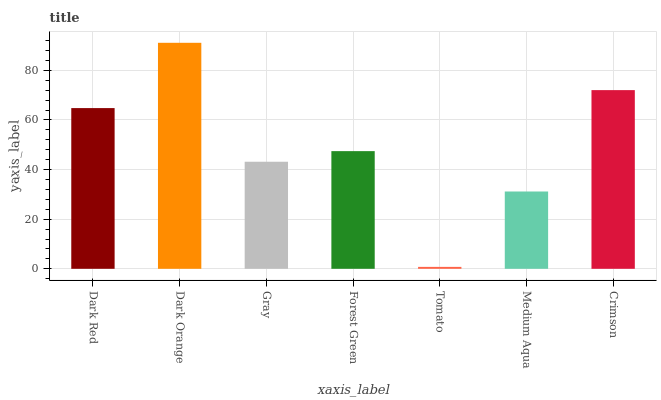Is Tomato the minimum?
Answer yes or no. Yes. Is Dark Orange the maximum?
Answer yes or no. Yes. Is Gray the minimum?
Answer yes or no. No. Is Gray the maximum?
Answer yes or no. No. Is Dark Orange greater than Gray?
Answer yes or no. Yes. Is Gray less than Dark Orange?
Answer yes or no. Yes. Is Gray greater than Dark Orange?
Answer yes or no. No. Is Dark Orange less than Gray?
Answer yes or no. No. Is Forest Green the high median?
Answer yes or no. Yes. Is Forest Green the low median?
Answer yes or no. Yes. Is Gray the high median?
Answer yes or no. No. Is Tomato the low median?
Answer yes or no. No. 